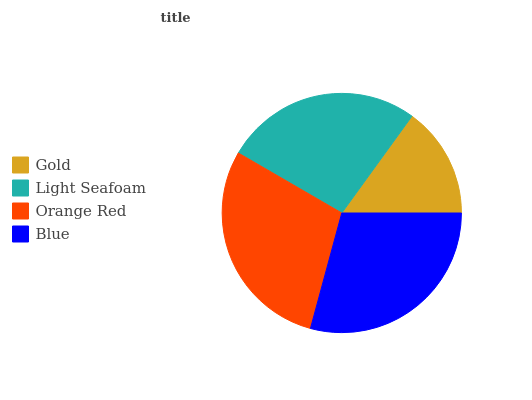Is Gold the minimum?
Answer yes or no. Yes. Is Blue the maximum?
Answer yes or no. Yes. Is Light Seafoam the minimum?
Answer yes or no. No. Is Light Seafoam the maximum?
Answer yes or no. No. Is Light Seafoam greater than Gold?
Answer yes or no. Yes. Is Gold less than Light Seafoam?
Answer yes or no. Yes. Is Gold greater than Light Seafoam?
Answer yes or no. No. Is Light Seafoam less than Gold?
Answer yes or no. No. Is Orange Red the high median?
Answer yes or no. Yes. Is Light Seafoam the low median?
Answer yes or no. Yes. Is Light Seafoam the high median?
Answer yes or no. No. Is Blue the low median?
Answer yes or no. No. 